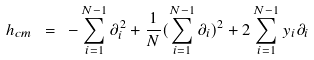Convert formula to latex. <formula><loc_0><loc_0><loc_500><loc_500>h _ { c m } \ = \ - \sum _ { i = 1 } ^ { N - 1 } \partial _ { i } ^ { 2 } + \frac { 1 } { N } ( \sum _ { i = 1 } ^ { N - 1 } \partial _ { i } ) ^ { 2 } + 2 \sum _ { i = 1 } ^ { N - 1 } y _ { i } \partial _ { i }</formula> 